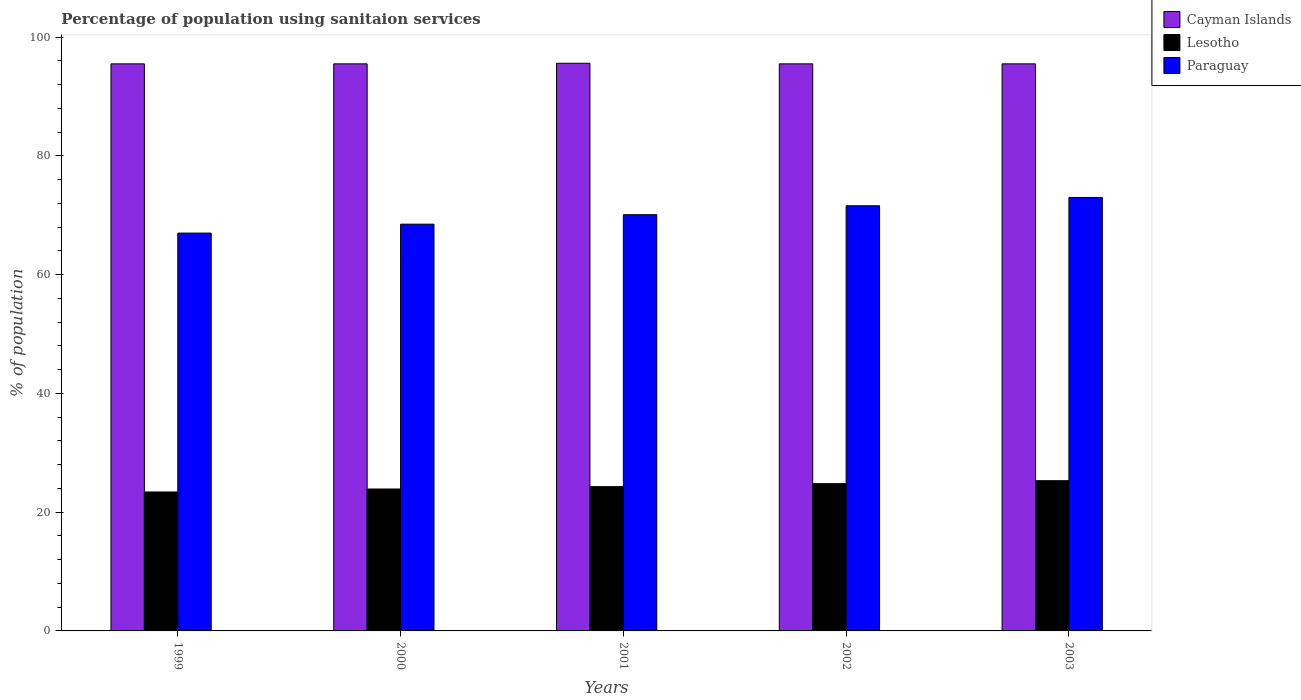How many different coloured bars are there?
Give a very brief answer. 3. How many bars are there on the 4th tick from the left?
Your response must be concise. 3. How many bars are there on the 5th tick from the right?
Make the answer very short. 3. In how many cases, is the number of bars for a given year not equal to the number of legend labels?
Your answer should be compact. 0. What is the percentage of population using sanitaion services in Lesotho in 2000?
Your answer should be compact. 23.9. Across all years, what is the maximum percentage of population using sanitaion services in Cayman Islands?
Your answer should be compact. 95.6. What is the total percentage of population using sanitaion services in Cayman Islands in the graph?
Your answer should be very brief. 477.6. What is the difference between the percentage of population using sanitaion services in Paraguay in 2001 and the percentage of population using sanitaion services in Cayman Islands in 1999?
Provide a succinct answer. -25.4. What is the average percentage of population using sanitaion services in Cayman Islands per year?
Make the answer very short. 95.52. In the year 2001, what is the difference between the percentage of population using sanitaion services in Cayman Islands and percentage of population using sanitaion services in Paraguay?
Ensure brevity in your answer.  25.5. In how many years, is the percentage of population using sanitaion services in Paraguay greater than 56 %?
Make the answer very short. 5. What is the ratio of the percentage of population using sanitaion services in Lesotho in 2002 to that in 2003?
Provide a succinct answer. 0.98. Is the percentage of population using sanitaion services in Cayman Islands in 1999 less than that in 2000?
Offer a very short reply. No. Is the difference between the percentage of population using sanitaion services in Cayman Islands in 2002 and 2003 greater than the difference between the percentage of population using sanitaion services in Paraguay in 2002 and 2003?
Provide a short and direct response. Yes. What is the difference between the highest and the second highest percentage of population using sanitaion services in Paraguay?
Your response must be concise. 1.4. What is the difference between the highest and the lowest percentage of population using sanitaion services in Paraguay?
Offer a very short reply. 6. In how many years, is the percentage of population using sanitaion services in Cayman Islands greater than the average percentage of population using sanitaion services in Cayman Islands taken over all years?
Offer a very short reply. 1. Is the sum of the percentage of population using sanitaion services in Lesotho in 1999 and 2001 greater than the maximum percentage of population using sanitaion services in Paraguay across all years?
Make the answer very short. No. What does the 1st bar from the left in 1999 represents?
Ensure brevity in your answer.  Cayman Islands. What does the 3rd bar from the right in 2000 represents?
Provide a short and direct response. Cayman Islands. What is the difference between two consecutive major ticks on the Y-axis?
Provide a short and direct response. 20. Are the values on the major ticks of Y-axis written in scientific E-notation?
Your response must be concise. No. Does the graph contain any zero values?
Your answer should be compact. No. How many legend labels are there?
Your response must be concise. 3. How are the legend labels stacked?
Provide a short and direct response. Vertical. What is the title of the graph?
Offer a terse response. Percentage of population using sanitaion services. What is the label or title of the Y-axis?
Your response must be concise. % of population. What is the % of population of Cayman Islands in 1999?
Your response must be concise. 95.5. What is the % of population in Lesotho in 1999?
Provide a short and direct response. 23.4. What is the % of population in Cayman Islands in 2000?
Provide a short and direct response. 95.5. What is the % of population of Lesotho in 2000?
Give a very brief answer. 23.9. What is the % of population of Paraguay in 2000?
Give a very brief answer. 68.5. What is the % of population in Cayman Islands in 2001?
Your response must be concise. 95.6. What is the % of population in Lesotho in 2001?
Give a very brief answer. 24.3. What is the % of population in Paraguay in 2001?
Provide a succinct answer. 70.1. What is the % of population of Cayman Islands in 2002?
Offer a very short reply. 95.5. What is the % of population of Lesotho in 2002?
Provide a succinct answer. 24.8. What is the % of population in Paraguay in 2002?
Offer a terse response. 71.6. What is the % of population in Cayman Islands in 2003?
Offer a terse response. 95.5. What is the % of population in Lesotho in 2003?
Give a very brief answer. 25.3. What is the % of population in Paraguay in 2003?
Your answer should be compact. 73. Across all years, what is the maximum % of population of Cayman Islands?
Give a very brief answer. 95.6. Across all years, what is the maximum % of population of Lesotho?
Keep it short and to the point. 25.3. Across all years, what is the maximum % of population in Paraguay?
Provide a succinct answer. 73. Across all years, what is the minimum % of population in Cayman Islands?
Offer a terse response. 95.5. Across all years, what is the minimum % of population of Lesotho?
Give a very brief answer. 23.4. What is the total % of population in Cayman Islands in the graph?
Provide a succinct answer. 477.6. What is the total % of population of Lesotho in the graph?
Offer a terse response. 121.7. What is the total % of population in Paraguay in the graph?
Provide a succinct answer. 350.2. What is the difference between the % of population in Paraguay in 1999 and that in 2000?
Provide a short and direct response. -1.5. What is the difference between the % of population in Lesotho in 1999 and that in 2002?
Provide a short and direct response. -1.4. What is the difference between the % of population of Paraguay in 1999 and that in 2002?
Keep it short and to the point. -4.6. What is the difference between the % of population of Lesotho in 1999 and that in 2003?
Offer a terse response. -1.9. What is the difference between the % of population in Paraguay in 1999 and that in 2003?
Your answer should be very brief. -6. What is the difference between the % of population of Lesotho in 2000 and that in 2001?
Give a very brief answer. -0.4. What is the difference between the % of population of Paraguay in 2000 and that in 2001?
Offer a very short reply. -1.6. What is the difference between the % of population of Lesotho in 2000 and that in 2002?
Offer a very short reply. -0.9. What is the difference between the % of population in Paraguay in 2000 and that in 2002?
Make the answer very short. -3.1. What is the difference between the % of population in Cayman Islands in 2000 and that in 2003?
Offer a very short reply. 0. What is the difference between the % of population of Lesotho in 2000 and that in 2003?
Ensure brevity in your answer.  -1.4. What is the difference between the % of population in Paraguay in 2000 and that in 2003?
Your answer should be compact. -4.5. What is the difference between the % of population in Lesotho in 2001 and that in 2002?
Your answer should be very brief. -0.5. What is the difference between the % of population of Paraguay in 2001 and that in 2002?
Offer a terse response. -1.5. What is the difference between the % of population in Paraguay in 2001 and that in 2003?
Your answer should be very brief. -2.9. What is the difference between the % of population of Paraguay in 2002 and that in 2003?
Ensure brevity in your answer.  -1.4. What is the difference between the % of population of Cayman Islands in 1999 and the % of population of Lesotho in 2000?
Provide a short and direct response. 71.6. What is the difference between the % of population in Lesotho in 1999 and the % of population in Paraguay in 2000?
Offer a very short reply. -45.1. What is the difference between the % of population in Cayman Islands in 1999 and the % of population in Lesotho in 2001?
Offer a very short reply. 71.2. What is the difference between the % of population of Cayman Islands in 1999 and the % of population of Paraguay in 2001?
Your response must be concise. 25.4. What is the difference between the % of population in Lesotho in 1999 and the % of population in Paraguay in 2001?
Keep it short and to the point. -46.7. What is the difference between the % of population in Cayman Islands in 1999 and the % of population in Lesotho in 2002?
Make the answer very short. 70.7. What is the difference between the % of population in Cayman Islands in 1999 and the % of population in Paraguay in 2002?
Your answer should be very brief. 23.9. What is the difference between the % of population of Lesotho in 1999 and the % of population of Paraguay in 2002?
Provide a short and direct response. -48.2. What is the difference between the % of population of Cayman Islands in 1999 and the % of population of Lesotho in 2003?
Offer a very short reply. 70.2. What is the difference between the % of population in Lesotho in 1999 and the % of population in Paraguay in 2003?
Provide a succinct answer. -49.6. What is the difference between the % of population of Cayman Islands in 2000 and the % of population of Lesotho in 2001?
Your response must be concise. 71.2. What is the difference between the % of population in Cayman Islands in 2000 and the % of population in Paraguay in 2001?
Your response must be concise. 25.4. What is the difference between the % of population of Lesotho in 2000 and the % of population of Paraguay in 2001?
Your answer should be compact. -46.2. What is the difference between the % of population in Cayman Islands in 2000 and the % of population in Lesotho in 2002?
Provide a short and direct response. 70.7. What is the difference between the % of population in Cayman Islands in 2000 and the % of population in Paraguay in 2002?
Provide a succinct answer. 23.9. What is the difference between the % of population of Lesotho in 2000 and the % of population of Paraguay in 2002?
Your answer should be very brief. -47.7. What is the difference between the % of population of Cayman Islands in 2000 and the % of population of Lesotho in 2003?
Provide a short and direct response. 70.2. What is the difference between the % of population in Lesotho in 2000 and the % of population in Paraguay in 2003?
Your answer should be compact. -49.1. What is the difference between the % of population of Cayman Islands in 2001 and the % of population of Lesotho in 2002?
Your answer should be compact. 70.8. What is the difference between the % of population in Lesotho in 2001 and the % of population in Paraguay in 2002?
Your answer should be compact. -47.3. What is the difference between the % of population of Cayman Islands in 2001 and the % of population of Lesotho in 2003?
Provide a succinct answer. 70.3. What is the difference between the % of population in Cayman Islands in 2001 and the % of population in Paraguay in 2003?
Keep it short and to the point. 22.6. What is the difference between the % of population of Lesotho in 2001 and the % of population of Paraguay in 2003?
Your answer should be compact. -48.7. What is the difference between the % of population of Cayman Islands in 2002 and the % of population of Lesotho in 2003?
Give a very brief answer. 70.2. What is the difference between the % of population in Cayman Islands in 2002 and the % of population in Paraguay in 2003?
Keep it short and to the point. 22.5. What is the difference between the % of population of Lesotho in 2002 and the % of population of Paraguay in 2003?
Offer a very short reply. -48.2. What is the average % of population in Cayman Islands per year?
Offer a very short reply. 95.52. What is the average % of population in Lesotho per year?
Your answer should be very brief. 24.34. What is the average % of population of Paraguay per year?
Offer a very short reply. 70.04. In the year 1999, what is the difference between the % of population in Cayman Islands and % of population in Lesotho?
Provide a succinct answer. 72.1. In the year 1999, what is the difference between the % of population in Cayman Islands and % of population in Paraguay?
Make the answer very short. 28.5. In the year 1999, what is the difference between the % of population in Lesotho and % of population in Paraguay?
Your response must be concise. -43.6. In the year 2000, what is the difference between the % of population in Cayman Islands and % of population in Lesotho?
Make the answer very short. 71.6. In the year 2000, what is the difference between the % of population in Lesotho and % of population in Paraguay?
Provide a succinct answer. -44.6. In the year 2001, what is the difference between the % of population of Cayman Islands and % of population of Lesotho?
Make the answer very short. 71.3. In the year 2001, what is the difference between the % of population in Cayman Islands and % of population in Paraguay?
Provide a succinct answer. 25.5. In the year 2001, what is the difference between the % of population of Lesotho and % of population of Paraguay?
Give a very brief answer. -45.8. In the year 2002, what is the difference between the % of population in Cayman Islands and % of population in Lesotho?
Give a very brief answer. 70.7. In the year 2002, what is the difference between the % of population in Cayman Islands and % of population in Paraguay?
Give a very brief answer. 23.9. In the year 2002, what is the difference between the % of population in Lesotho and % of population in Paraguay?
Your answer should be compact. -46.8. In the year 2003, what is the difference between the % of population in Cayman Islands and % of population in Lesotho?
Provide a short and direct response. 70.2. In the year 2003, what is the difference between the % of population of Cayman Islands and % of population of Paraguay?
Provide a succinct answer. 22.5. In the year 2003, what is the difference between the % of population of Lesotho and % of population of Paraguay?
Ensure brevity in your answer.  -47.7. What is the ratio of the % of population in Lesotho in 1999 to that in 2000?
Provide a succinct answer. 0.98. What is the ratio of the % of population of Paraguay in 1999 to that in 2000?
Make the answer very short. 0.98. What is the ratio of the % of population in Lesotho in 1999 to that in 2001?
Make the answer very short. 0.96. What is the ratio of the % of population of Paraguay in 1999 to that in 2001?
Keep it short and to the point. 0.96. What is the ratio of the % of population of Cayman Islands in 1999 to that in 2002?
Give a very brief answer. 1. What is the ratio of the % of population of Lesotho in 1999 to that in 2002?
Ensure brevity in your answer.  0.94. What is the ratio of the % of population in Paraguay in 1999 to that in 2002?
Offer a very short reply. 0.94. What is the ratio of the % of population of Lesotho in 1999 to that in 2003?
Your answer should be very brief. 0.92. What is the ratio of the % of population in Paraguay in 1999 to that in 2003?
Keep it short and to the point. 0.92. What is the ratio of the % of population of Lesotho in 2000 to that in 2001?
Keep it short and to the point. 0.98. What is the ratio of the % of population of Paraguay in 2000 to that in 2001?
Your answer should be compact. 0.98. What is the ratio of the % of population of Lesotho in 2000 to that in 2002?
Keep it short and to the point. 0.96. What is the ratio of the % of population in Paraguay in 2000 to that in 2002?
Your answer should be very brief. 0.96. What is the ratio of the % of population of Cayman Islands in 2000 to that in 2003?
Offer a terse response. 1. What is the ratio of the % of population of Lesotho in 2000 to that in 2003?
Make the answer very short. 0.94. What is the ratio of the % of population of Paraguay in 2000 to that in 2003?
Your answer should be very brief. 0.94. What is the ratio of the % of population in Cayman Islands in 2001 to that in 2002?
Your answer should be compact. 1. What is the ratio of the % of population in Lesotho in 2001 to that in 2002?
Your response must be concise. 0.98. What is the ratio of the % of population in Paraguay in 2001 to that in 2002?
Provide a short and direct response. 0.98. What is the ratio of the % of population of Lesotho in 2001 to that in 2003?
Keep it short and to the point. 0.96. What is the ratio of the % of population of Paraguay in 2001 to that in 2003?
Ensure brevity in your answer.  0.96. What is the ratio of the % of population of Lesotho in 2002 to that in 2003?
Your response must be concise. 0.98. What is the ratio of the % of population of Paraguay in 2002 to that in 2003?
Make the answer very short. 0.98. What is the difference between the highest and the second highest % of population of Cayman Islands?
Provide a short and direct response. 0.1. What is the difference between the highest and the second highest % of population in Lesotho?
Offer a terse response. 0.5. What is the difference between the highest and the lowest % of population of Lesotho?
Keep it short and to the point. 1.9. What is the difference between the highest and the lowest % of population in Paraguay?
Offer a very short reply. 6. 